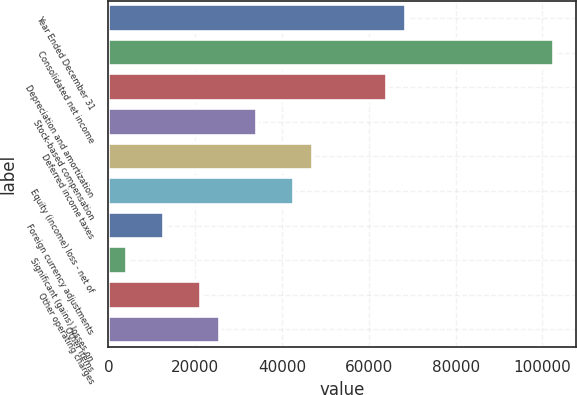Convert chart to OTSL. <chart><loc_0><loc_0><loc_500><loc_500><bar_chart><fcel>Year Ended December 31<fcel>Consolidated net income<fcel>Depreciation and amortization<fcel>Stock-based compensation<fcel>Deferred income taxes<fcel>Equity (income) loss - net of<fcel>Foreign currency adjustments<fcel>Significant (gains) losses on<fcel>Other operating charges<fcel>Other items<nl><fcel>68453.6<fcel>102670<fcel>64176.5<fcel>34236.8<fcel>47068.1<fcel>42791<fcel>12851.3<fcel>4297.1<fcel>21405.5<fcel>25682.6<nl></chart> 